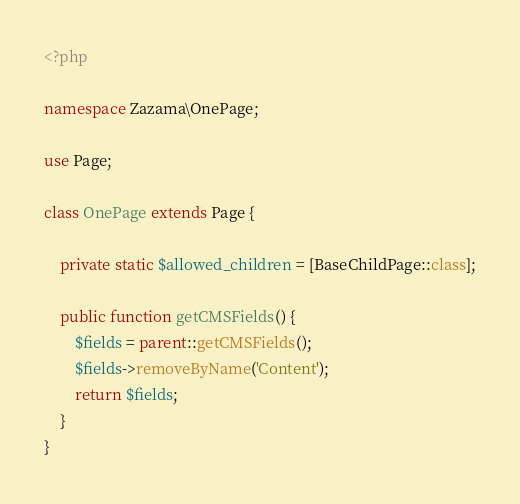Convert code to text. <code><loc_0><loc_0><loc_500><loc_500><_PHP_><?php

namespace Zazama\OnePage;

use Page;

class OnePage extends Page {

    private static $allowed_children = [BaseChildPage::class];

    public function getCMSFields() {
        $fields = parent::getCMSFields();
        $fields->removeByName('Content');
        return $fields;
    }
}</code> 